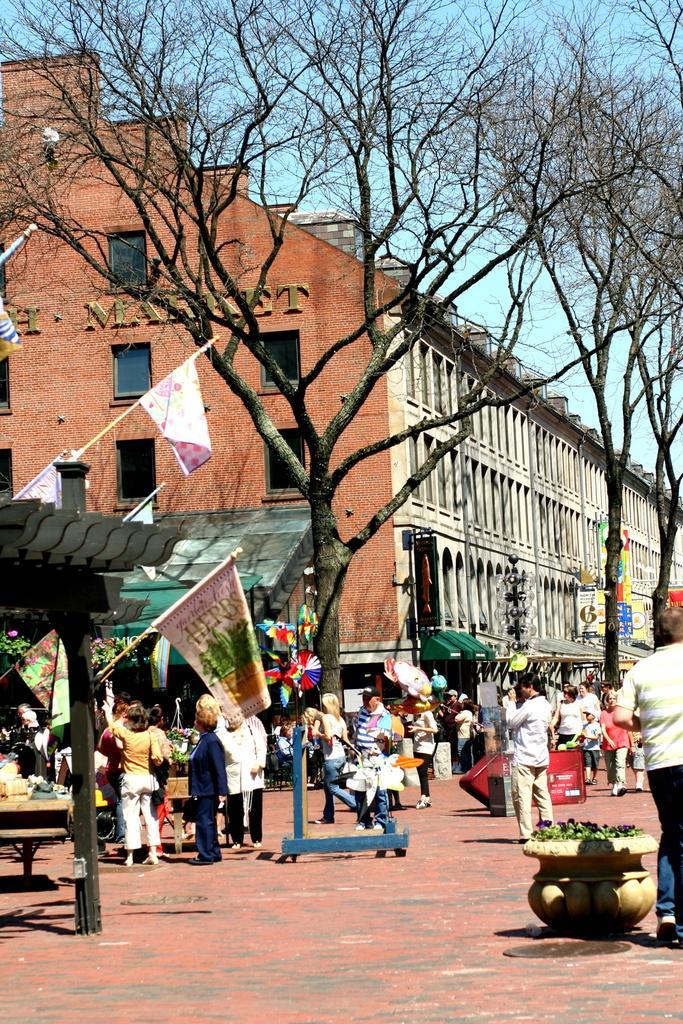In one or two sentences, can you explain what this image depicts? In the middle of the image few people are standing and walking and there are some plants. At the top of the image there are some trees. Behind the trees there is a building and sky. 